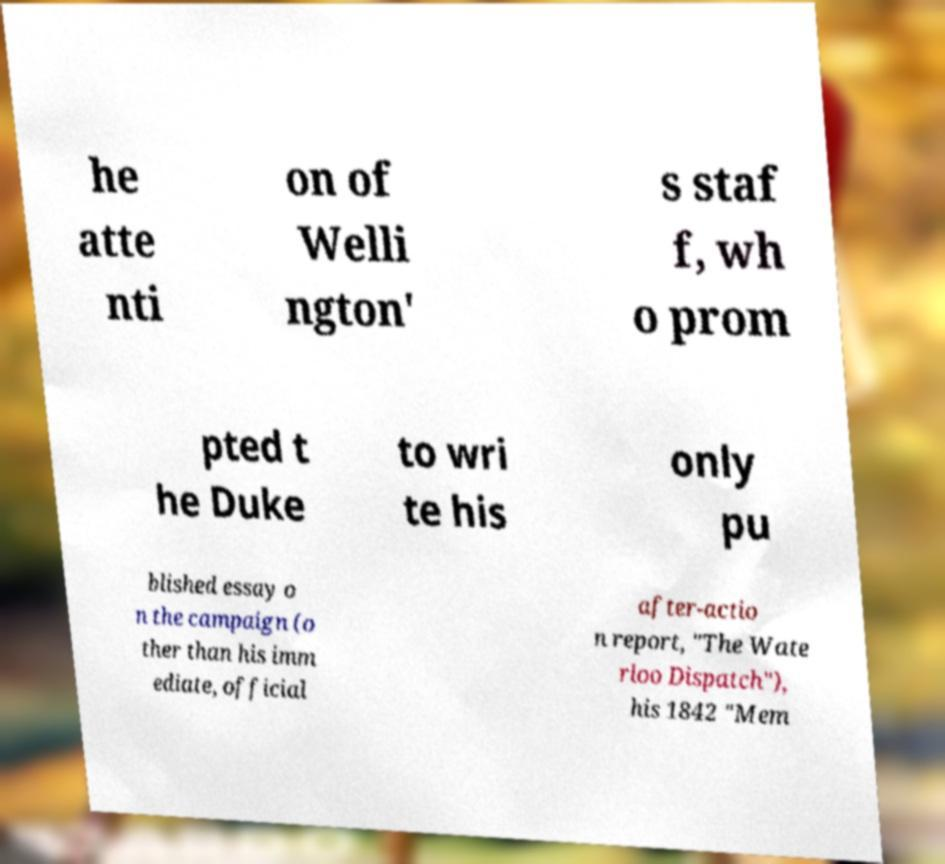What messages or text are displayed in this image? I need them in a readable, typed format. he atte nti on of Welli ngton' s staf f, wh o prom pted t he Duke to wri te his only pu blished essay o n the campaign (o ther than his imm ediate, official after-actio n report, "The Wate rloo Dispatch"), his 1842 "Mem 